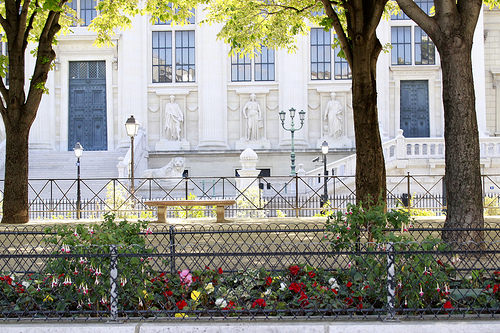<image>
Is there a palace in front of the tree? No. The palace is not in front of the tree. The spatial positioning shows a different relationship between these objects. 